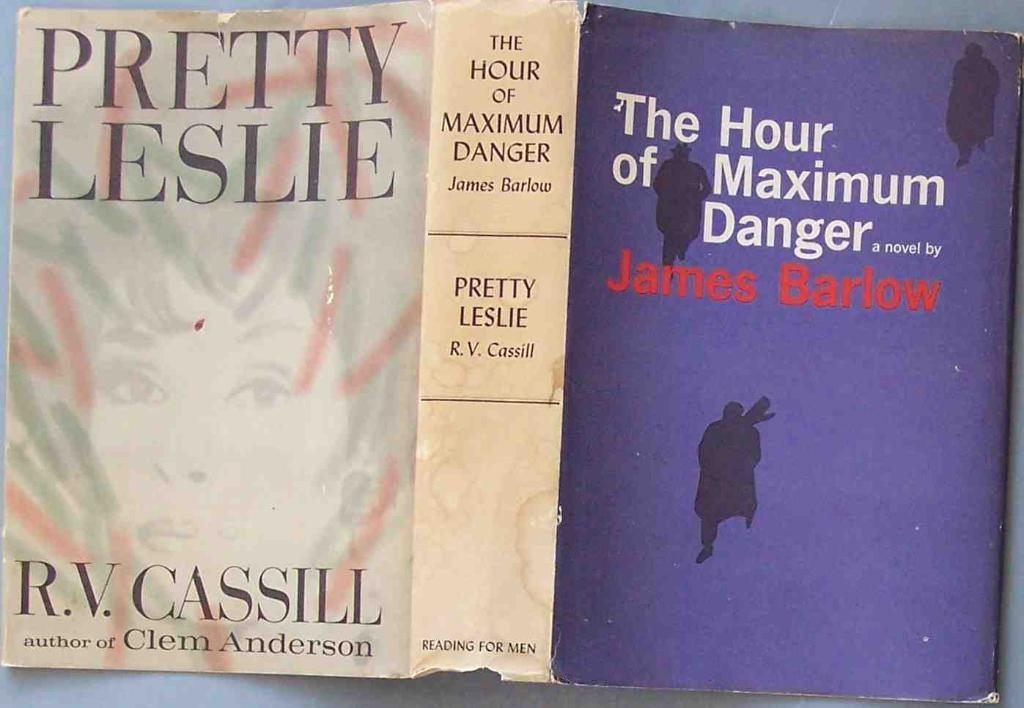<image>
Describe the image concisely. A novel by James Barlow entitled The Hour of Maximum Danger 